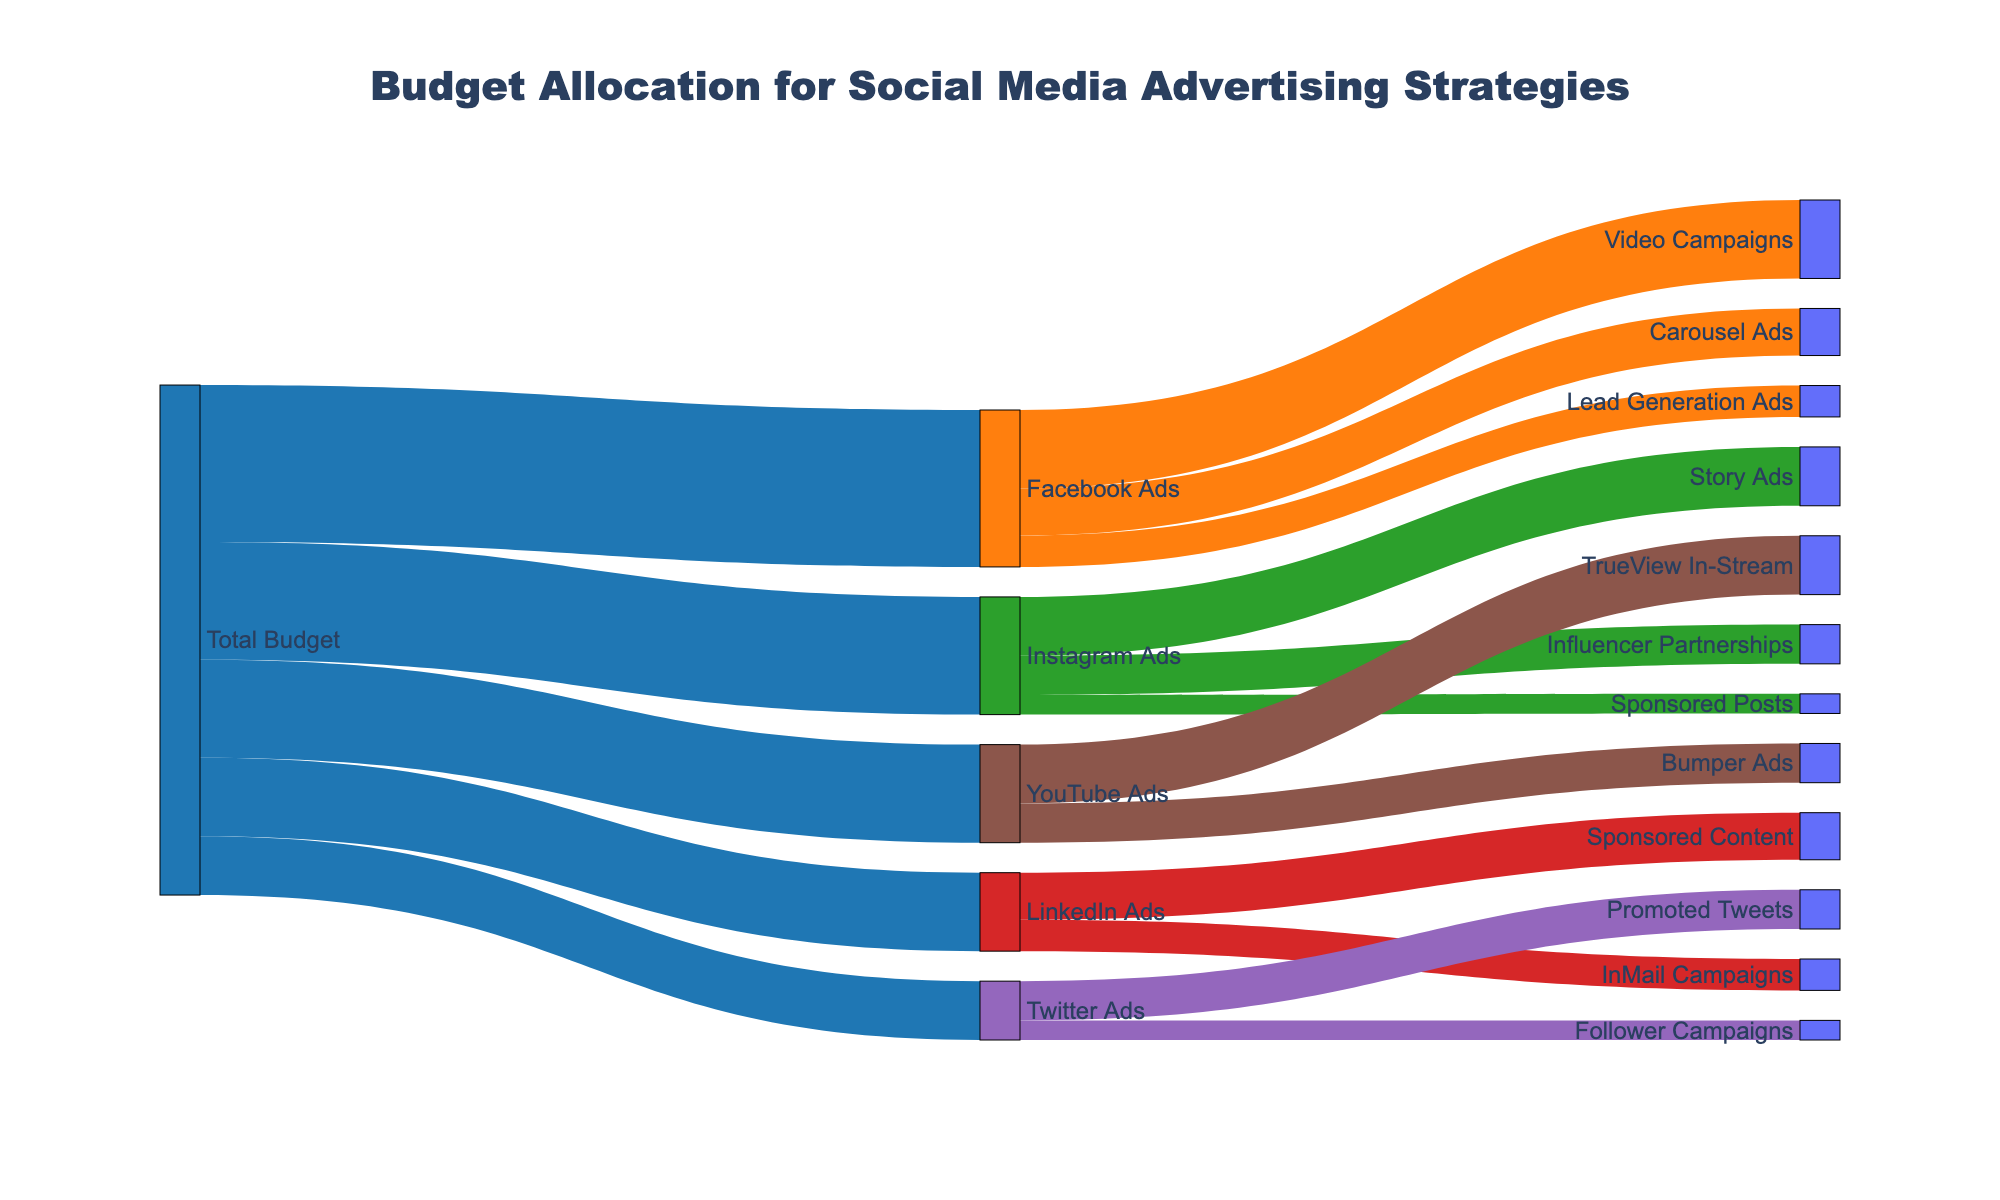What's the title of the Sankey Diagram? Looking at the diagram, the title is typically displayed at the top of the figure.
Answer: Budget Allocation for Social Media Advertising Strategies What is the total budget allocated to Facebook Ads? The total budget can be found by checking the value associated with the flow from "Total Budget" to "Facebook Ads".
Answer: 40000 Which type of Facebook Ad received the highest allocation? To find this, look at the values associated with the different types of Facebook Ads. Compare Video Campaigns, Carousel Ads, and Lead Generation Ads.
Answer: Video Campaigns How much more budget is allocated to Instagram Ads compared to LinkedIn Ads? First, identify the budget for Instagram Ads and LinkedIn Ads, then subtract the LinkedIn Ads budget from the Instagram Ads budget (30000 - 20000).
Answer: 10000 Among the Instagram Ads, which received the least budget? Identify the values allocated to Story Ads, Influencer Partnerships, and Sponsored Posts, and find the smallest value.
Answer: Sponsored Posts How much total budget is allocated across all YouTube Ads? Add up the values for TrueView In-Stream and Bumper Ads (15000 + 10000).
Answer: 25000 Which social media platform received the smallest total budget allocation from the Total Budget? Compare the values allocated to Facebook Ads, Instagram Ads, LinkedIn Ads, Twitter Ads, and YouTube Ads, and find the smallest value.
Answer: Twitter Ads Which type of Twitter Ad received the highest allocation? Compare values between Promoted Tweets and Follower Campaigns and select the higher value.
Answer: Promoted Tweets What's the total budget allocated to all ads combined? Sum the values allocated to each platform's ads from the Total Budget (40000 + 30000 + 20000 + 15000 + 25000).
Answer: 130000 How does the budget for Facebook Carousel Ads compare to LinkedIn InMail Campaigns? Find the value for Carousel Ads and compare it to the value for InMail Campaigns to see which is higher.
Answer: Carousel Ads: 12000, InMail Campaigns: 8000 